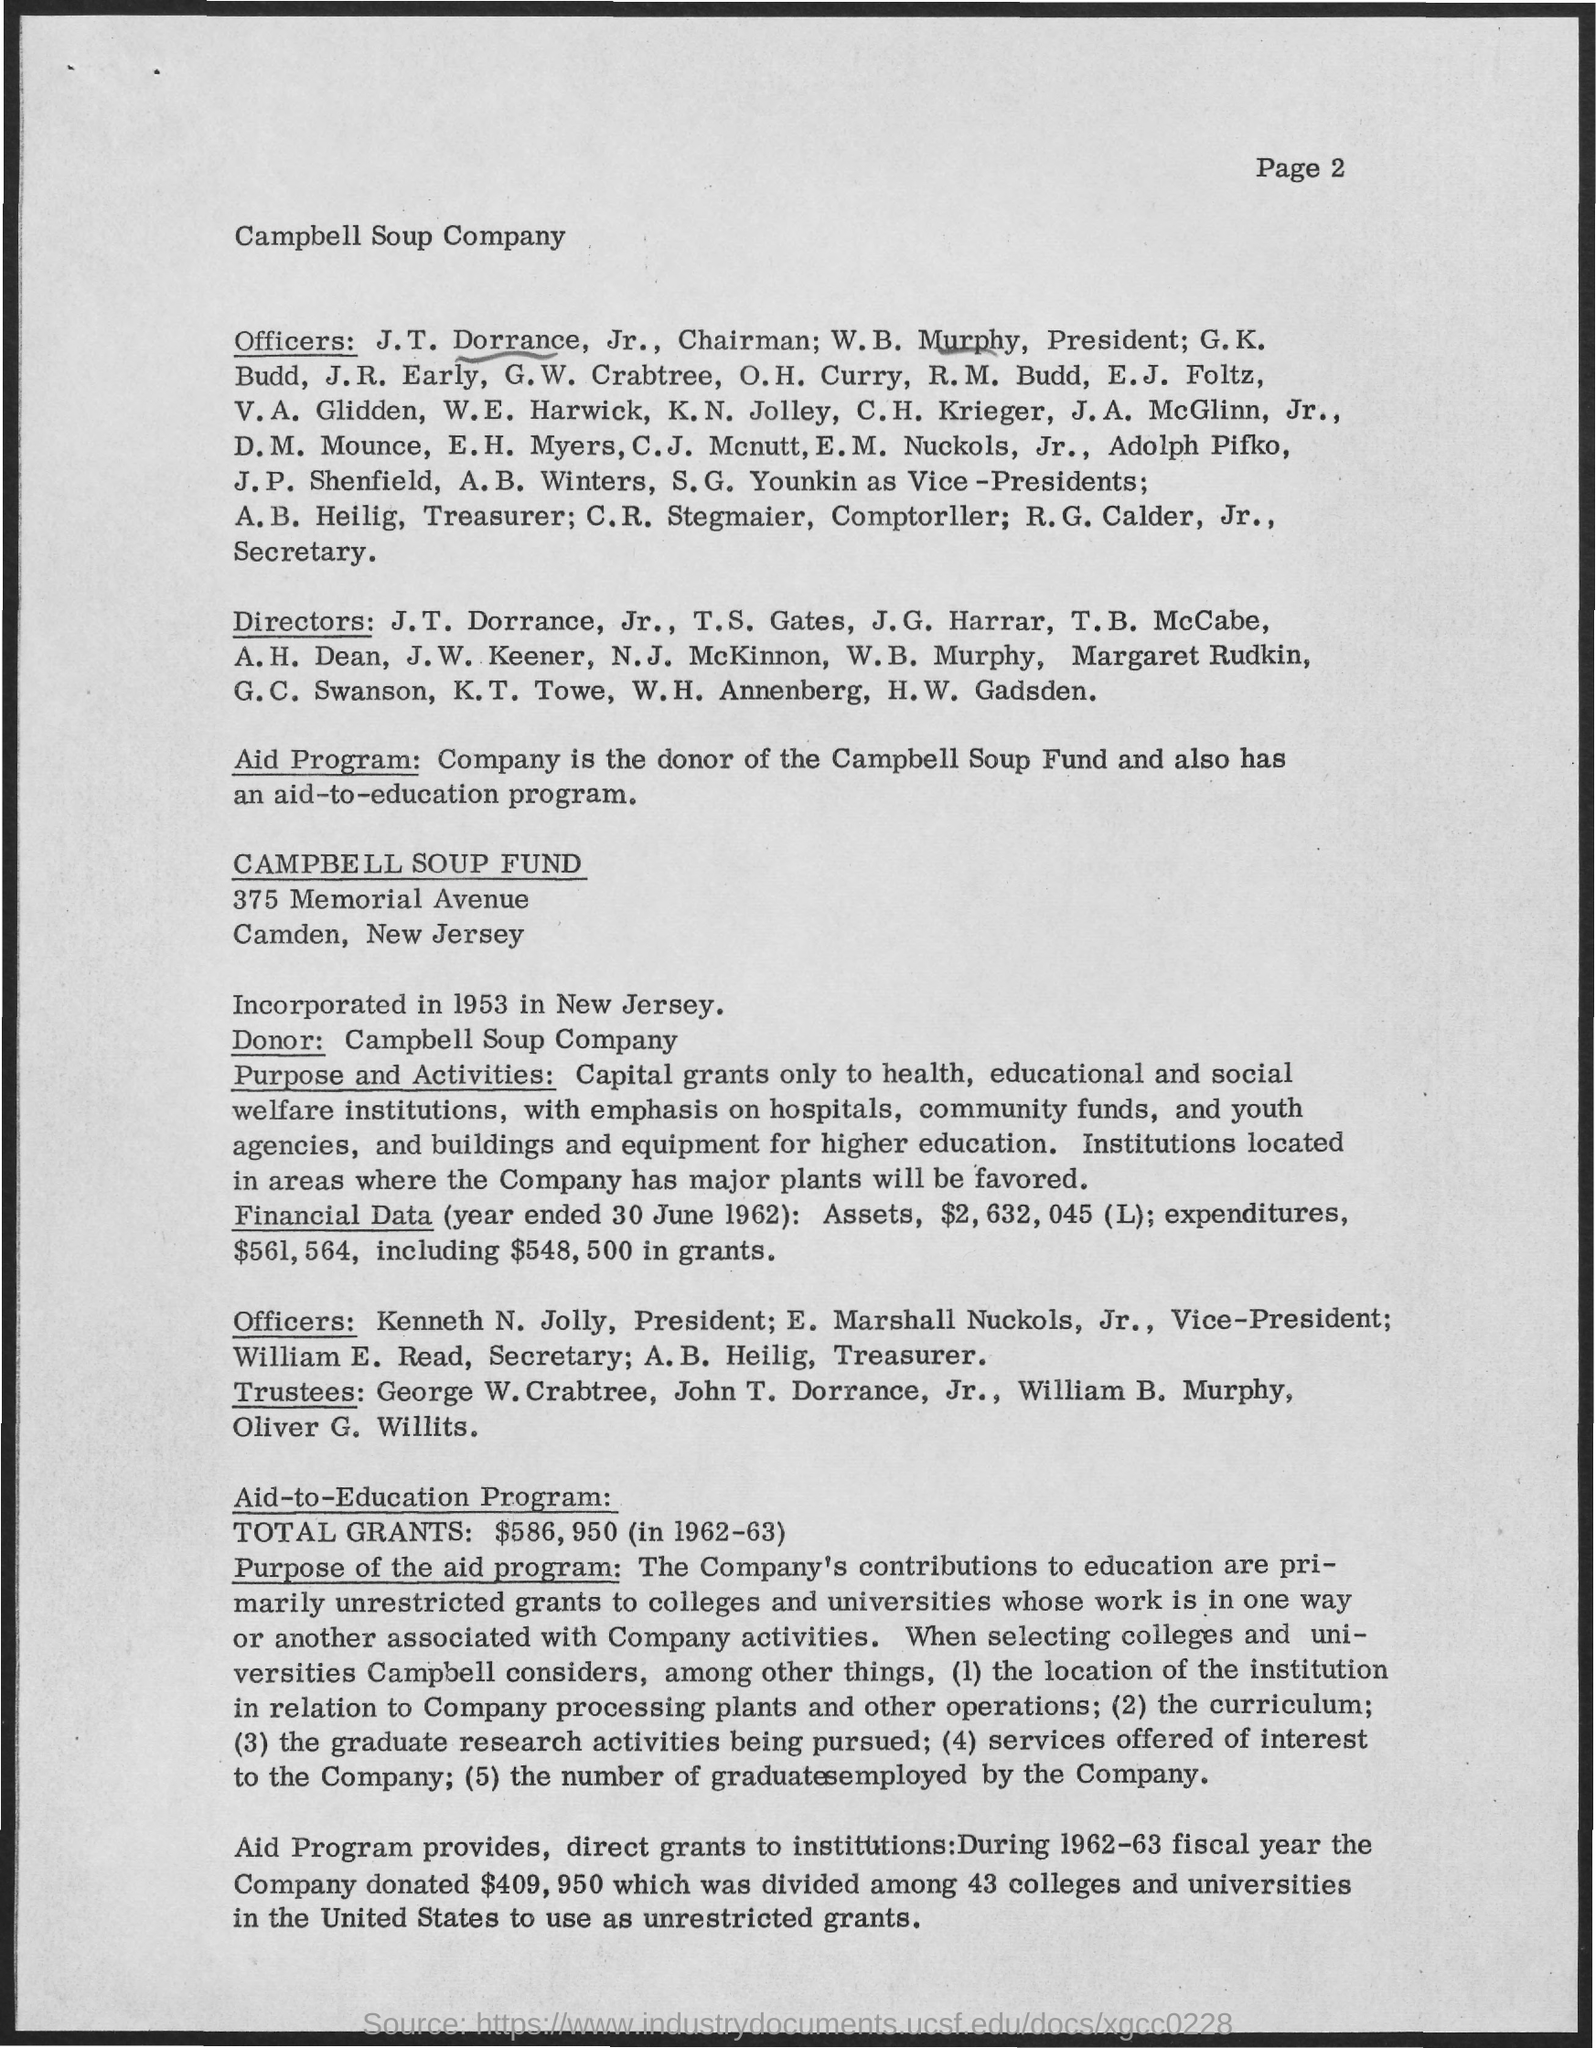Which company's name is mentioned?
Provide a succinct answer. Campbell Soup Company. Where was the Campbell Soup Fund incorporated?
Offer a very short reply. In new jersey. When was the Campbell Soup Fund incorporated?
Your response must be concise. In 1953. Who is the donor?
Keep it short and to the point. Campbell Soup Company. What was the amount of the total grants in 1962-63?
Offer a terse response. $586, 950. 